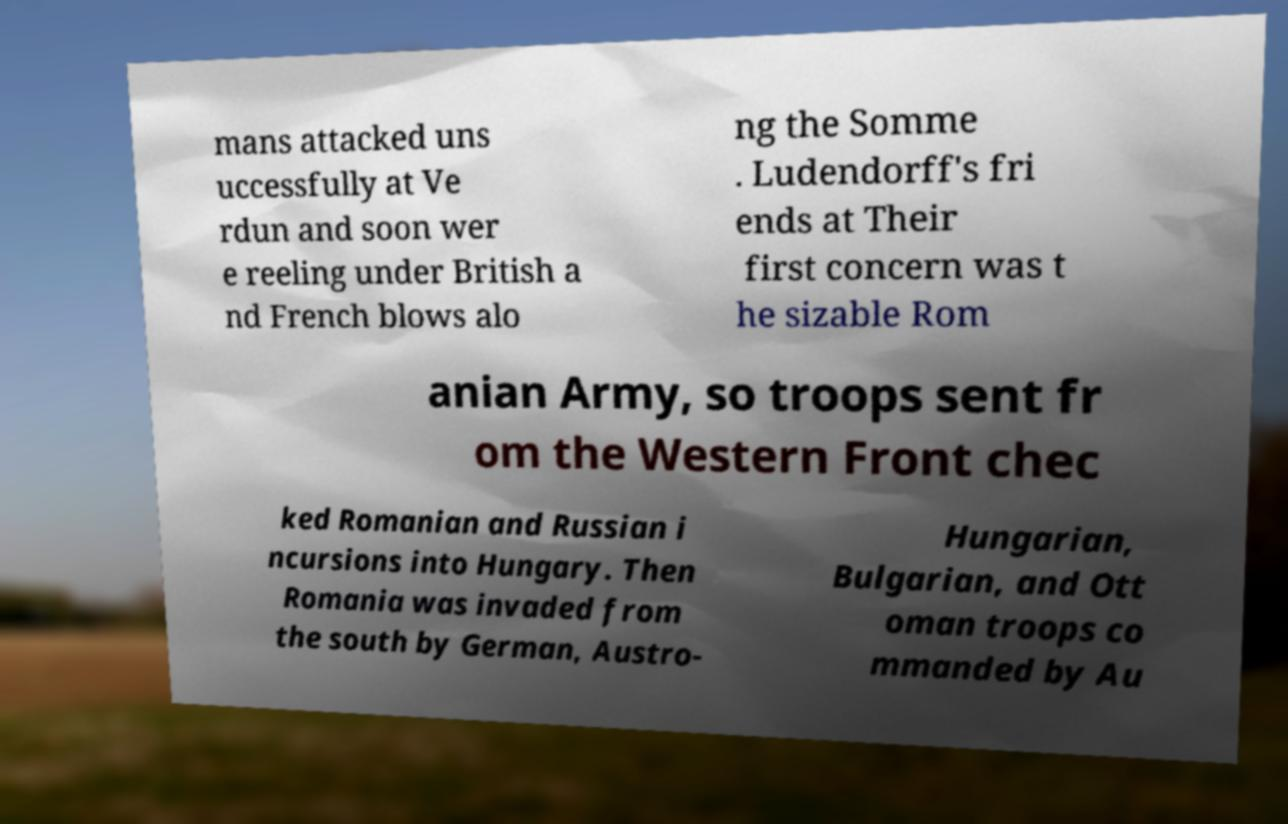Can you accurately transcribe the text from the provided image for me? mans attacked uns uccessfully at Ve rdun and soon wer e reeling under British a nd French blows alo ng the Somme . Ludendorff's fri ends at Their first concern was t he sizable Rom anian Army, so troops sent fr om the Western Front chec ked Romanian and Russian i ncursions into Hungary. Then Romania was invaded from the south by German, Austro- Hungarian, Bulgarian, and Ott oman troops co mmanded by Au 